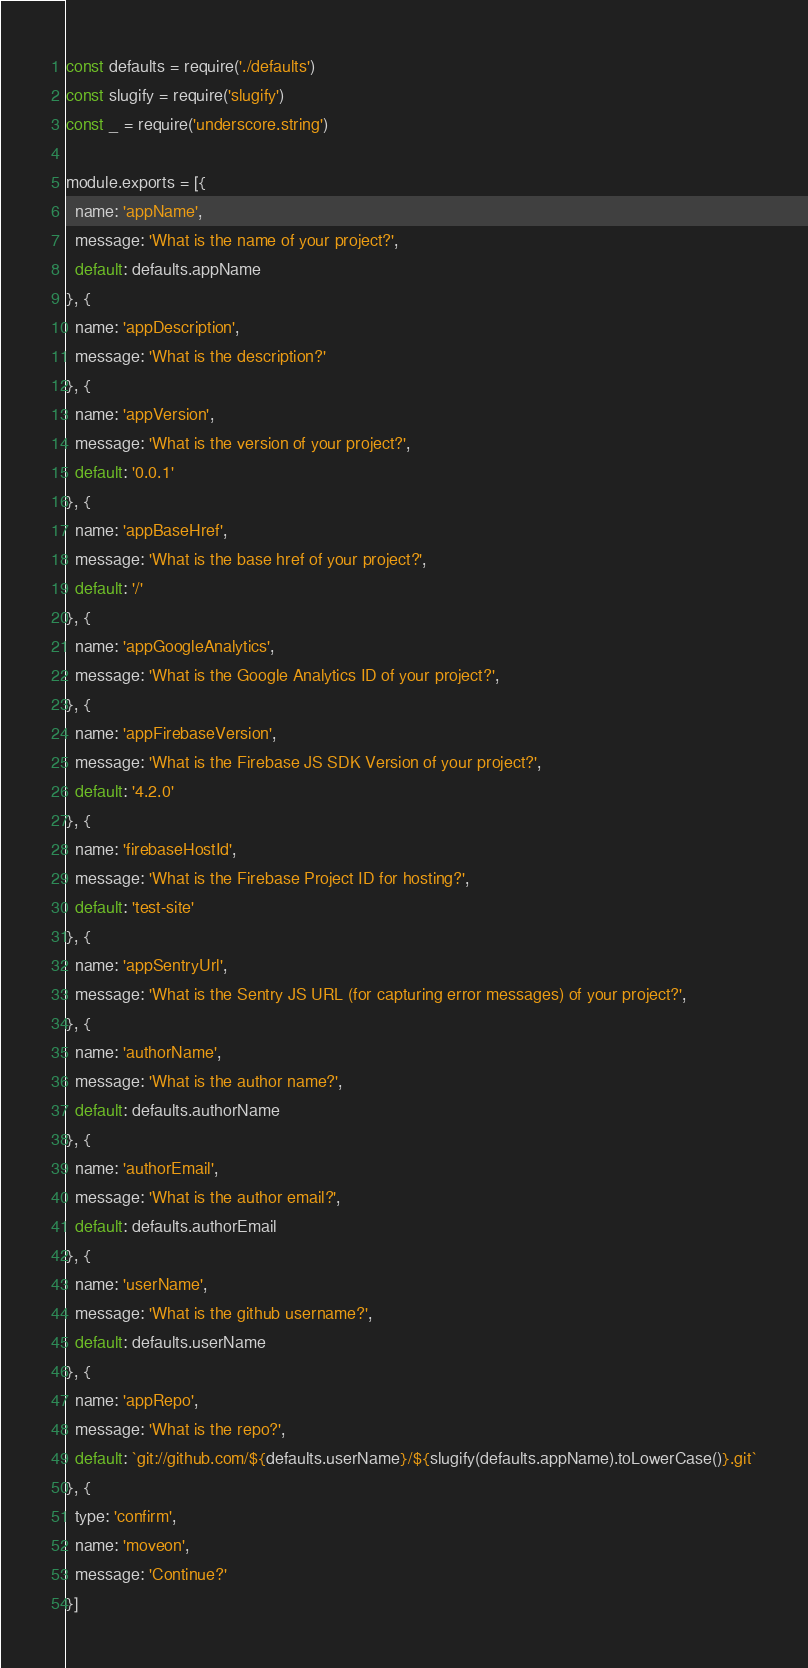<code> <loc_0><loc_0><loc_500><loc_500><_JavaScript_>const defaults = require('./defaults')
const slugify = require('slugify')
const _ = require('underscore.string')

module.exports = [{
  name: 'appName',
  message: 'What is the name of your project?',
  default: defaults.appName
}, {
  name: 'appDescription',
  message: 'What is the description?'
}, {
  name: 'appVersion',
  message: 'What is the version of your project?',
  default: '0.0.1'
}, {
  name: 'appBaseHref',
  message: 'What is the base href of your project?',
  default: '/'
}, {
  name: 'appGoogleAnalytics',
  message: 'What is the Google Analytics ID of your project?',
}, {
  name: 'appFirebaseVersion',
  message: 'What is the Firebase JS SDK Version of your project?',
  default: '4.2.0'
}, {
  name: 'firebaseHostId',
  message: 'What is the Firebase Project ID for hosting?',
  default: 'test-site'
}, {
  name: 'appSentryUrl',
  message: 'What is the Sentry JS URL (for capturing error messages) of your project?',
}, {
  name: 'authorName',
  message: 'What is the author name?',
  default: defaults.authorName
}, {
  name: 'authorEmail',
  message: 'What is the author email?',
  default: defaults.authorEmail
}, {
  name: 'userName',
  message: 'What is the github username?',
  default: defaults.userName
}, {
  name: 'appRepo',
  message: 'What is the repo?',
  default: `git://github.com/${defaults.userName}/${slugify(defaults.appName).toLowerCase()}.git`
}, {
  type: 'confirm',
  name: 'moveon',
  message: 'Continue?'
}]
</code> 